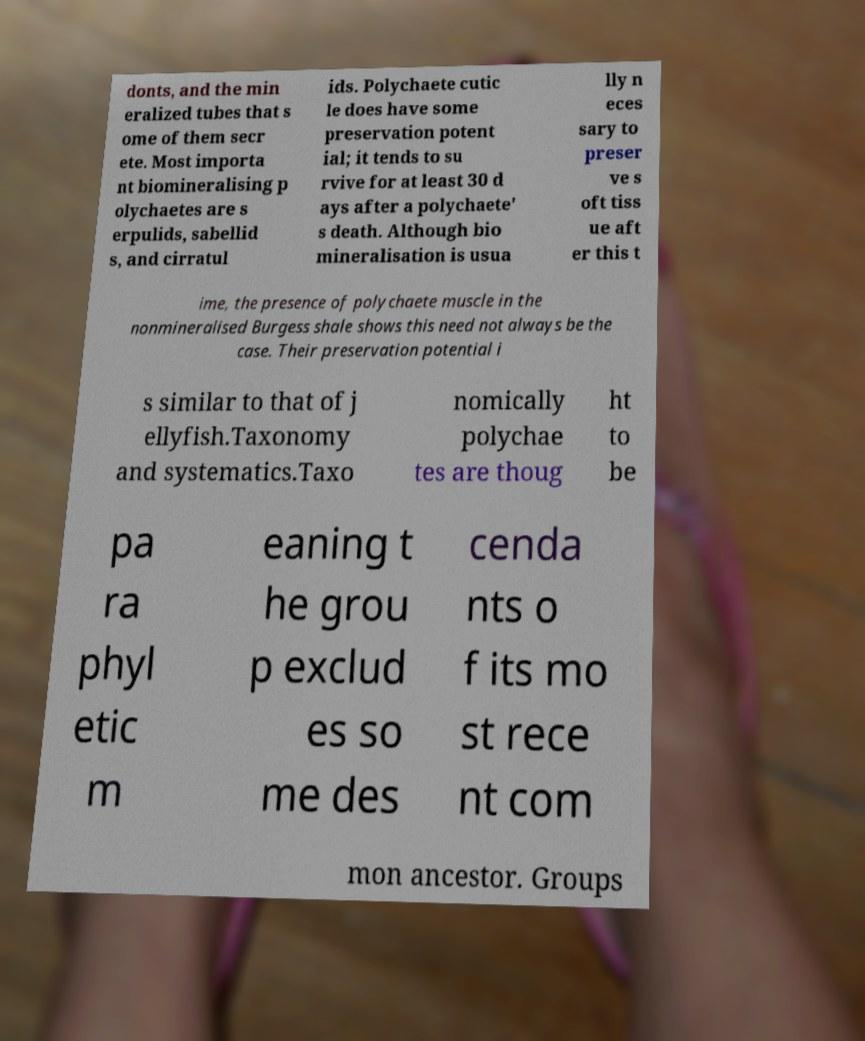I need the written content from this picture converted into text. Can you do that? donts, and the min eralized tubes that s ome of them secr ete. Most importa nt biomineralising p olychaetes are s erpulids, sabellid s, and cirratul ids. Polychaete cutic le does have some preservation potent ial; it tends to su rvive for at least 30 d ays after a polychaete' s death. Although bio mineralisation is usua lly n eces sary to preser ve s oft tiss ue aft er this t ime, the presence of polychaete muscle in the nonmineralised Burgess shale shows this need not always be the case. Their preservation potential i s similar to that of j ellyfish.Taxonomy and systematics.Taxo nomically polychae tes are thoug ht to be pa ra phyl etic m eaning t he grou p exclud es so me des cenda nts o f its mo st rece nt com mon ancestor. Groups 